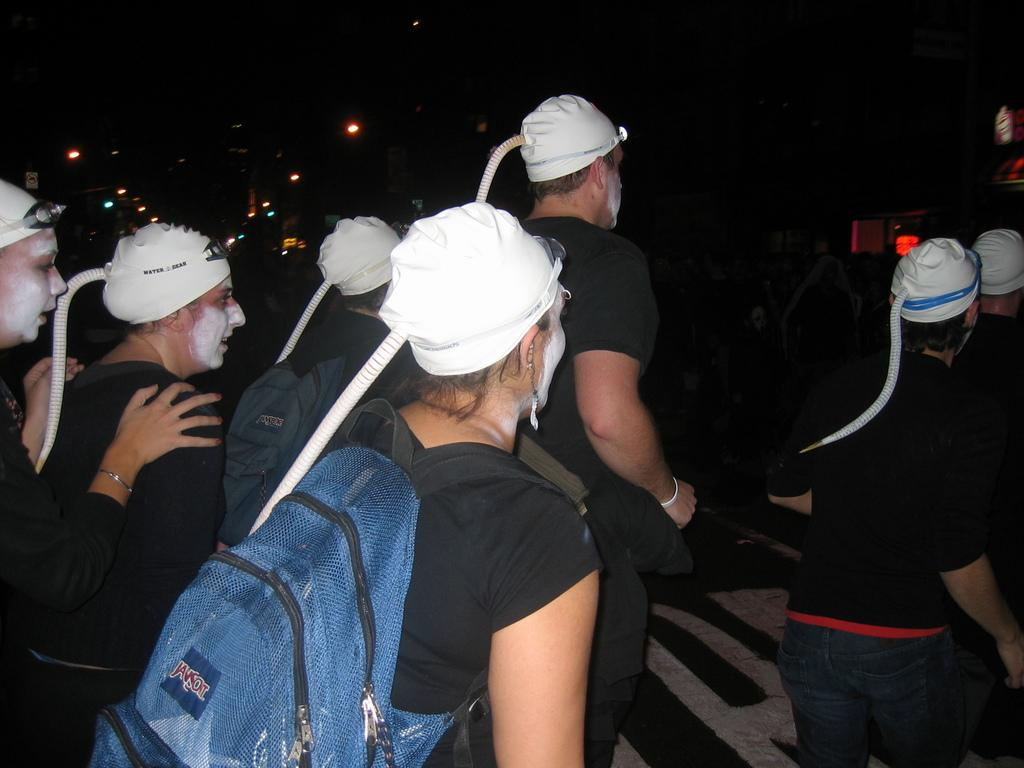Who is present in the image? There are people in the image. What are the people wearing on their heads? The people are wearing white caps. What are the people carrying? The people are carrying bags. What surface are the people walking on? The people are walking on a road. What can be seen in the background of the image? There are lamp posts in the background of the image. What type of sweater is the ray wearing in the image? There is no ray or sweater present in the image. How does the sense of the people change as they walk on the road? The image does not provide information about the people's sense of touch, smell, taste, hearing, or sight as they walk on the road. 